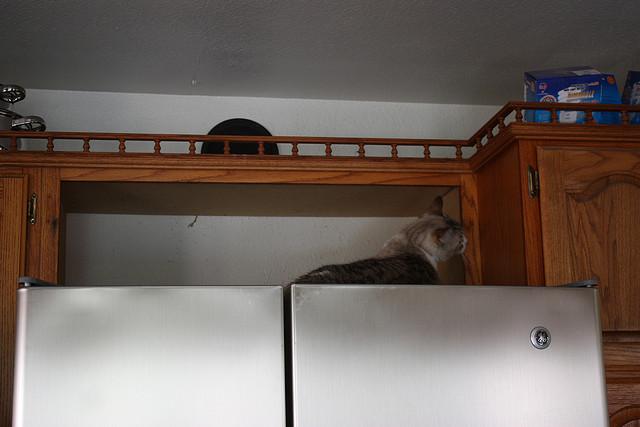What is on top of the fridge?
Short answer required. Cat. Is this cat full grown?
Give a very brief answer. Yes. What is in the box?
Write a very short answer. Nothing. What room is this?
Be succinct. Kitchen. Is the cat sleeping?
Write a very short answer. No. 